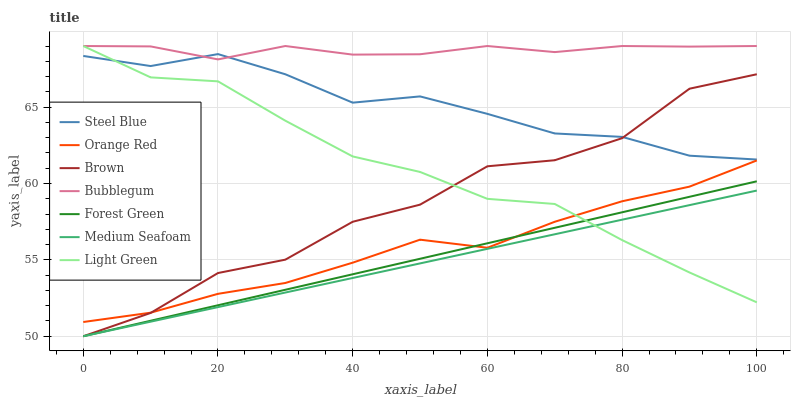Does Medium Seafoam have the minimum area under the curve?
Answer yes or no. Yes. Does Bubblegum have the maximum area under the curve?
Answer yes or no. Yes. Does Steel Blue have the minimum area under the curve?
Answer yes or no. No. Does Steel Blue have the maximum area under the curve?
Answer yes or no. No. Is Forest Green the smoothest?
Answer yes or no. Yes. Is Brown the roughest?
Answer yes or no. Yes. Is Steel Blue the smoothest?
Answer yes or no. No. Is Steel Blue the roughest?
Answer yes or no. No. Does Steel Blue have the lowest value?
Answer yes or no. No. Does Light Green have the highest value?
Answer yes or no. Yes. Does Steel Blue have the highest value?
Answer yes or no. No. Is Orange Red less than Steel Blue?
Answer yes or no. Yes. Is Orange Red greater than Medium Seafoam?
Answer yes or no. Yes. Does Light Green intersect Bubblegum?
Answer yes or no. Yes. Is Light Green less than Bubblegum?
Answer yes or no. No. Is Light Green greater than Bubblegum?
Answer yes or no. No. Does Orange Red intersect Steel Blue?
Answer yes or no. No. 